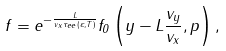<formula> <loc_0><loc_0><loc_500><loc_500>f = e ^ { - \frac { L } { v _ { x } \tau _ { e e } ( \varepsilon , T ) } } f _ { 0 } \left ( y - L \frac { v _ { y } } { v _ { x } } , { p } \right ) ,</formula> 